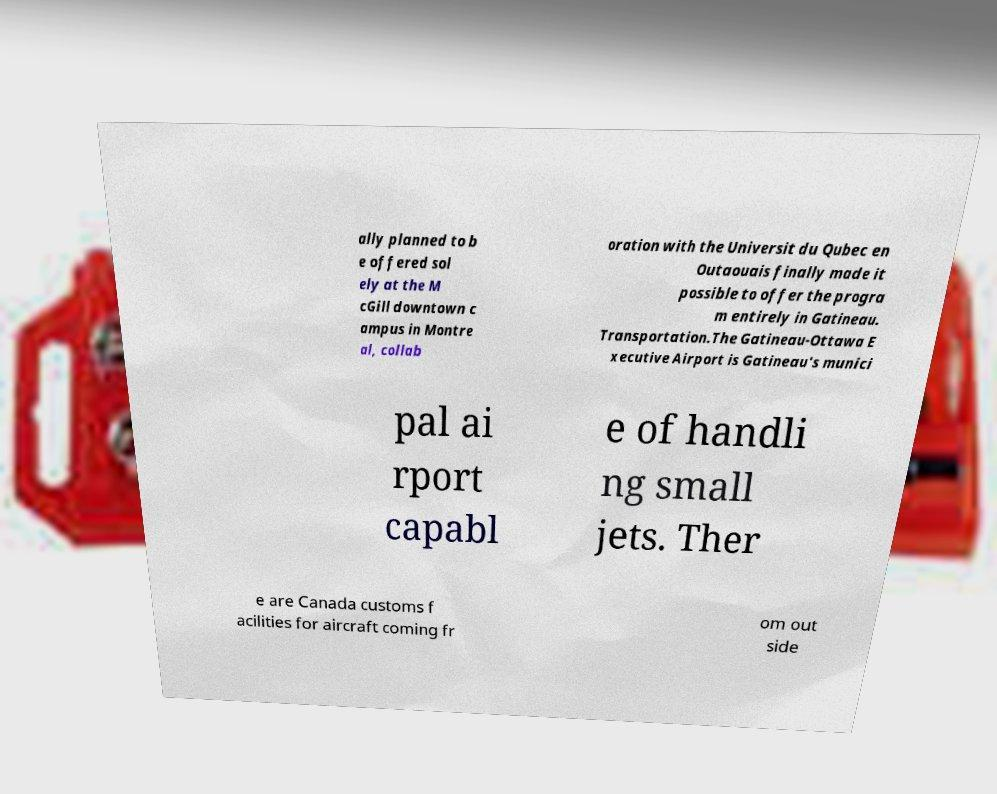I need the written content from this picture converted into text. Can you do that? ally planned to b e offered sol ely at the M cGill downtown c ampus in Montre al, collab oration with the Universit du Qubec en Outaouais finally made it possible to offer the progra m entirely in Gatineau. Transportation.The Gatineau-Ottawa E xecutive Airport is Gatineau's munici pal ai rport capabl e of handli ng small jets. Ther e are Canada customs f acilities for aircraft coming fr om out side 